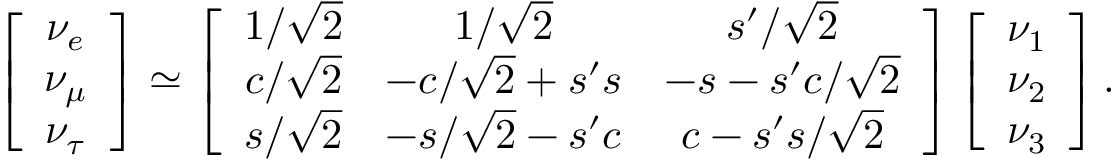Convert formula to latex. <formula><loc_0><loc_0><loc_500><loc_500>\left [ \begin{array} { c } { { \nu _ { e } } } \\ { { \nu _ { \mu } } } \\ { { \nu _ { \tau } } } \end{array} \right ] \simeq \left [ \begin{array} { c c c } { 1 / \sqrt { 2 } } & { 1 / \sqrt { 2 } } & { { s ^ { \prime } / \sqrt { 2 } } } \\ { c / \sqrt { 2 } } & { { - c / \sqrt { 2 } + s ^ { \prime } s } } & { { - s - s ^ { \prime } c / \sqrt { 2 } } } \\ { s / \sqrt { 2 } } & { { - s / \sqrt { 2 } - s ^ { \prime } c } } & { { c - s ^ { \prime } s / \sqrt { 2 } } } \end{array} \right ] \left [ \begin{array} { c } { { \nu _ { 1 } } } \\ { { \nu _ { 2 } } } \\ { { \nu _ { 3 } } } \end{array} \right ] .</formula> 